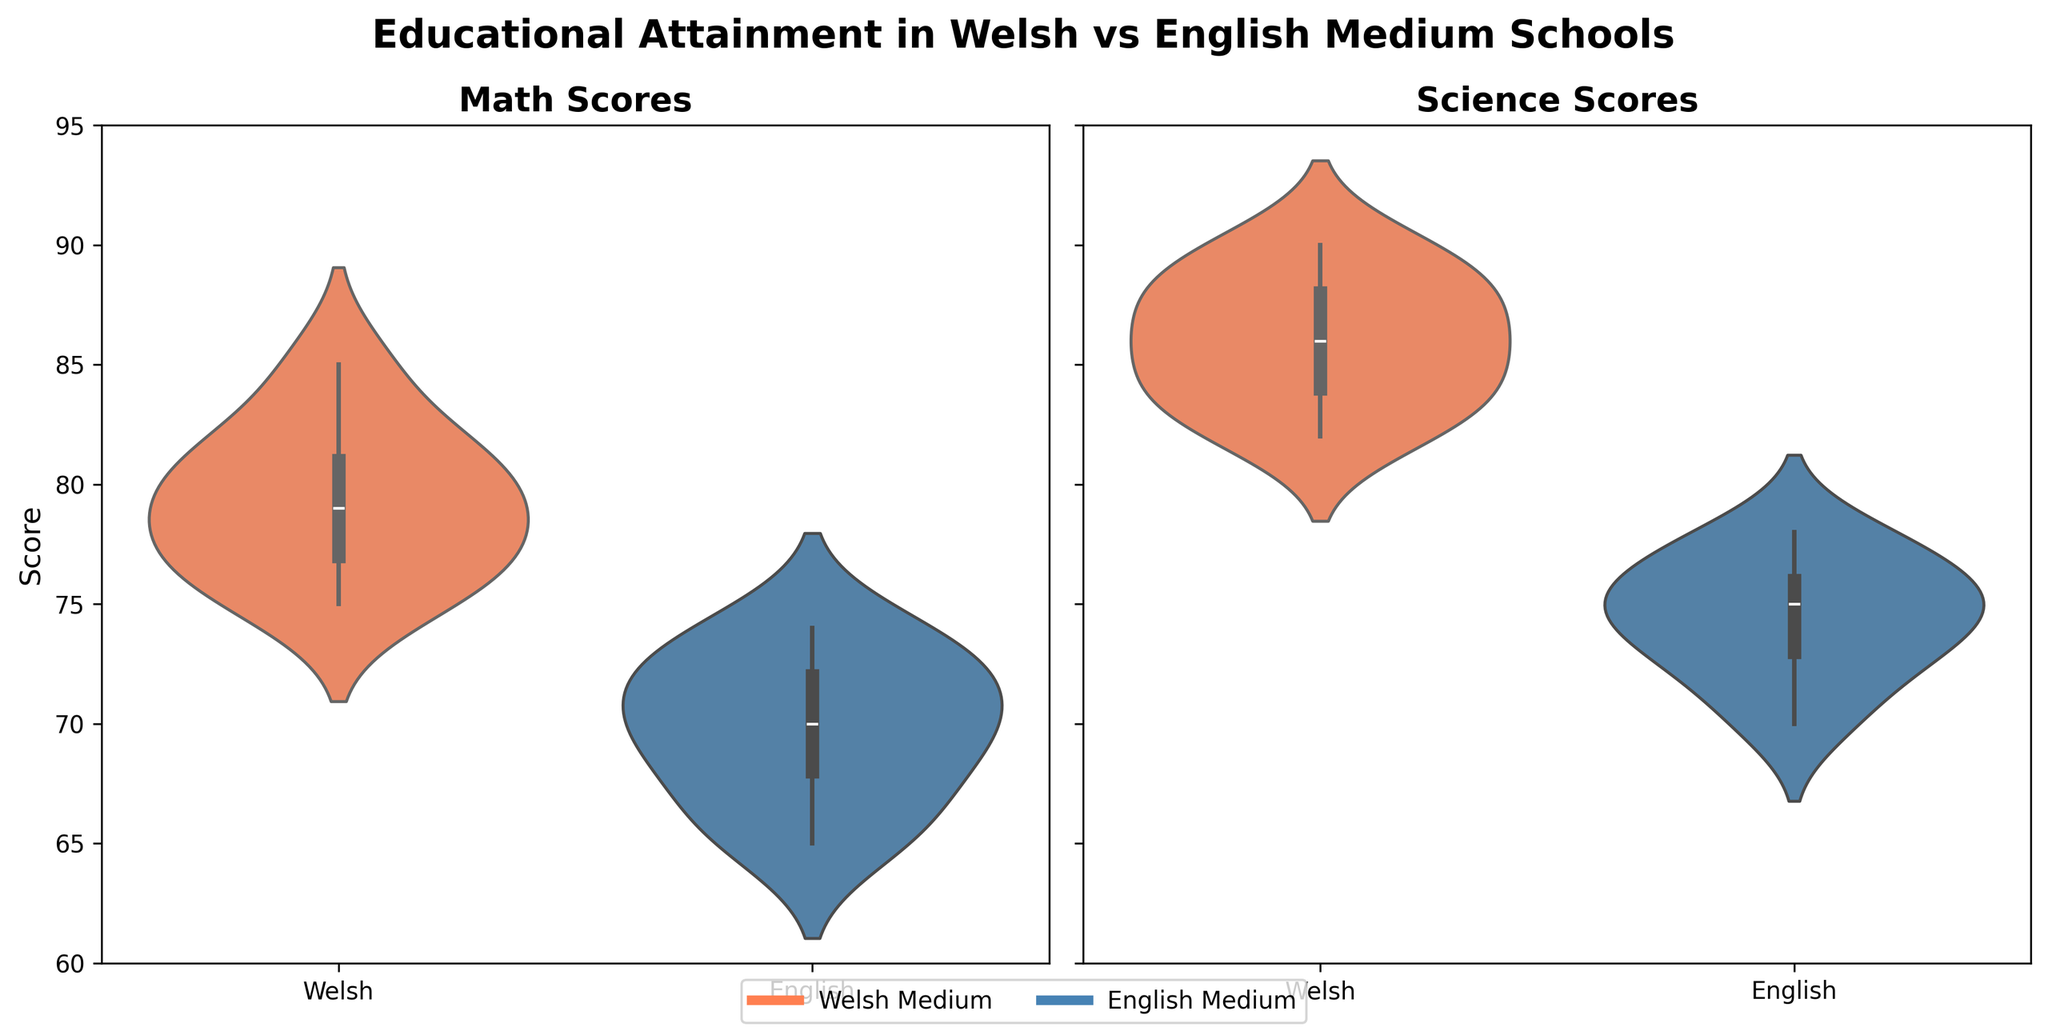What is the title of the figure? The title is displayed at the top of the figure and provides an overview of the content being represented.
Answer: Educational Attainment in Welsh vs English Medium Schools Which scores have a wider range in Welsh-medium schools, math or science? To determine which has a wider range, visually inspect the spread of the data in both the math and science violins for Welsh-medium schools. The science scores appear wider spread than the math scores.
Answer: Science scores What is the approximate median math score for English-medium schools in 2022? On the violin plot for math scores, the median is marked by the darker line inside the violin. For English-medium schools in 2022, it roughly aligns with a score of 70-73.
Answer: Approximately 70-73 Which medium of instruction shows higher median science scores? Look at the position of the thicker line (median) inside each violin in the science scores plot. The Welsh-medium violin's median line is higher than the English-medium's median line.
Answer: Welsh-medium Compare the outlier values in math scores for both mediums. Check the outermost points of the violin plots for math scores. Both mediums exhibit lower outliers, but the spread and values differ. Welsh-medium schools show scores above 85; English-medium show scores around 70.
Answer: Welsh: above 85, English: around 70 In which subject do Welsh-medium schools show less variability in scores? Examine the 'width' of the violin plots. Narrower plots indicate less variability. Both math and science plots for Welsh-medium are narrow, but math appears slightly narrower.
Answer: Math By comparing the shape of the distributions, which subject shows more consistency in score distribution for English-medium schools? Consistency can be inferred from a more symmetric and less spread-out violin plot. The science scores violin plot for English-medium schools is more symmetric and narrow compared to math.
Answer: Science What can be inferred about the overall performance of Welsh-medium schools compared to English-medium schools in science? Generally, Welsh-medium schools have a higher median and a higher upper quartile in science scores as shown by the thicker line and wider upper ends of the violin plot.
Answer: Higher overall performance Between the two subjects, which one shows more noticeable differences between Welsh and English medium schools? Compare the relative positions and spreads of both violin plots for math and science scores. Science scores show more noticeable differences with Welsh-medium schools scoring higher overall.
Answer: Science What insights can one draw about the trend in educational attainment between 2020 and 2022 based on the plotted data? Considering the violin plots show aggregated data over years, observe overall shifts in median lines. If Welsh-medium schools consistently position higher, it suggests maintaining or improving performance over time.
Answer: Welsh-medium schools maintain better attainment 